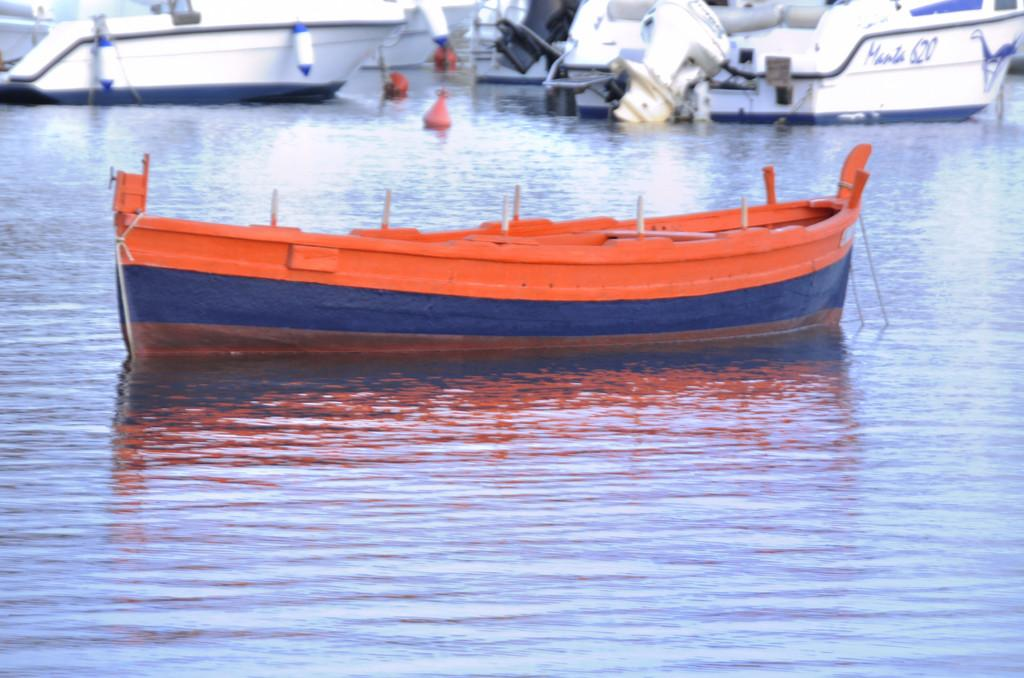<image>
Describe the image concisely. A red and blue row boat is in front of a white boat that says manta 620. 